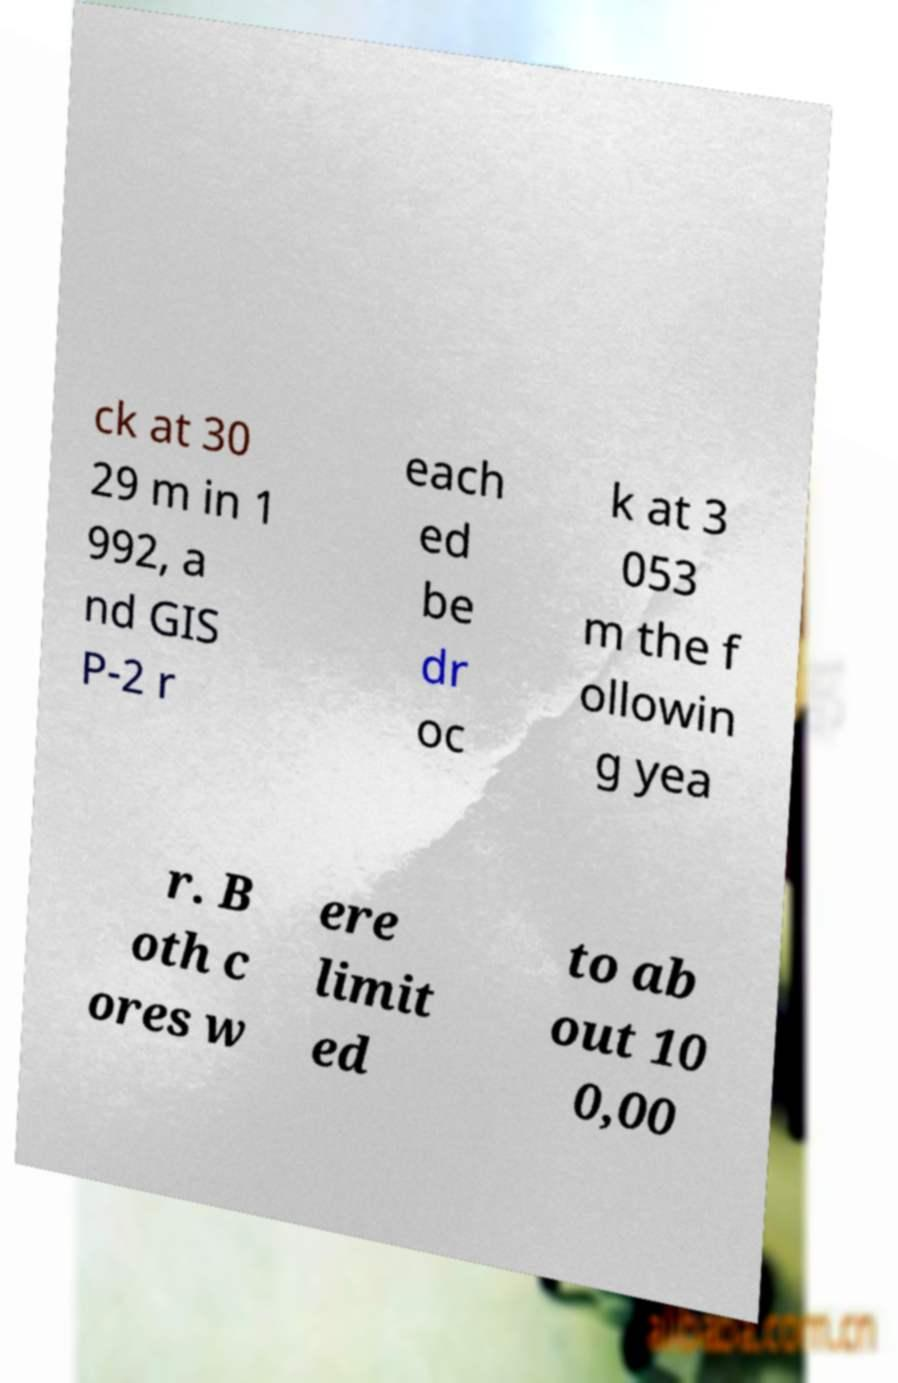I need the written content from this picture converted into text. Can you do that? ck at 30 29 m in 1 992, a nd GIS P-2 r each ed be dr oc k at 3 053 m the f ollowin g yea r. B oth c ores w ere limit ed to ab out 10 0,00 